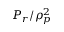<formula> <loc_0><loc_0><loc_500><loc_500>P _ { r } / \rho _ { p } ^ { 2 }</formula> 